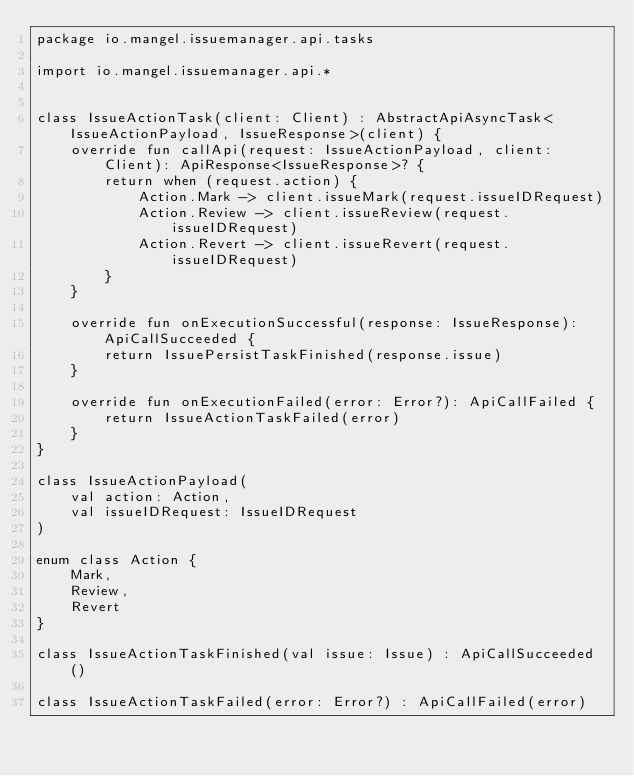Convert code to text. <code><loc_0><loc_0><loc_500><loc_500><_Kotlin_>package io.mangel.issuemanager.api.tasks

import io.mangel.issuemanager.api.*


class IssueActionTask(client: Client) : AbstractApiAsyncTask<IssueActionPayload, IssueResponse>(client) {
    override fun callApi(request: IssueActionPayload, client: Client): ApiResponse<IssueResponse>? {
        return when (request.action) {
            Action.Mark -> client.issueMark(request.issueIDRequest)
            Action.Review -> client.issueReview(request.issueIDRequest)
            Action.Revert -> client.issueRevert(request.issueIDRequest)
        }
    }

    override fun onExecutionSuccessful(response: IssueResponse): ApiCallSucceeded {
        return IssuePersistTaskFinished(response.issue)
    }

    override fun onExecutionFailed(error: Error?): ApiCallFailed {
        return IssueActionTaskFailed(error)
    }
}

class IssueActionPayload(
    val action: Action,
    val issueIDRequest: IssueIDRequest
)

enum class Action {
    Mark,
    Review,
    Revert
}

class IssueActionTaskFinished(val issue: Issue) : ApiCallSucceeded()

class IssueActionTaskFailed(error: Error?) : ApiCallFailed(error)</code> 